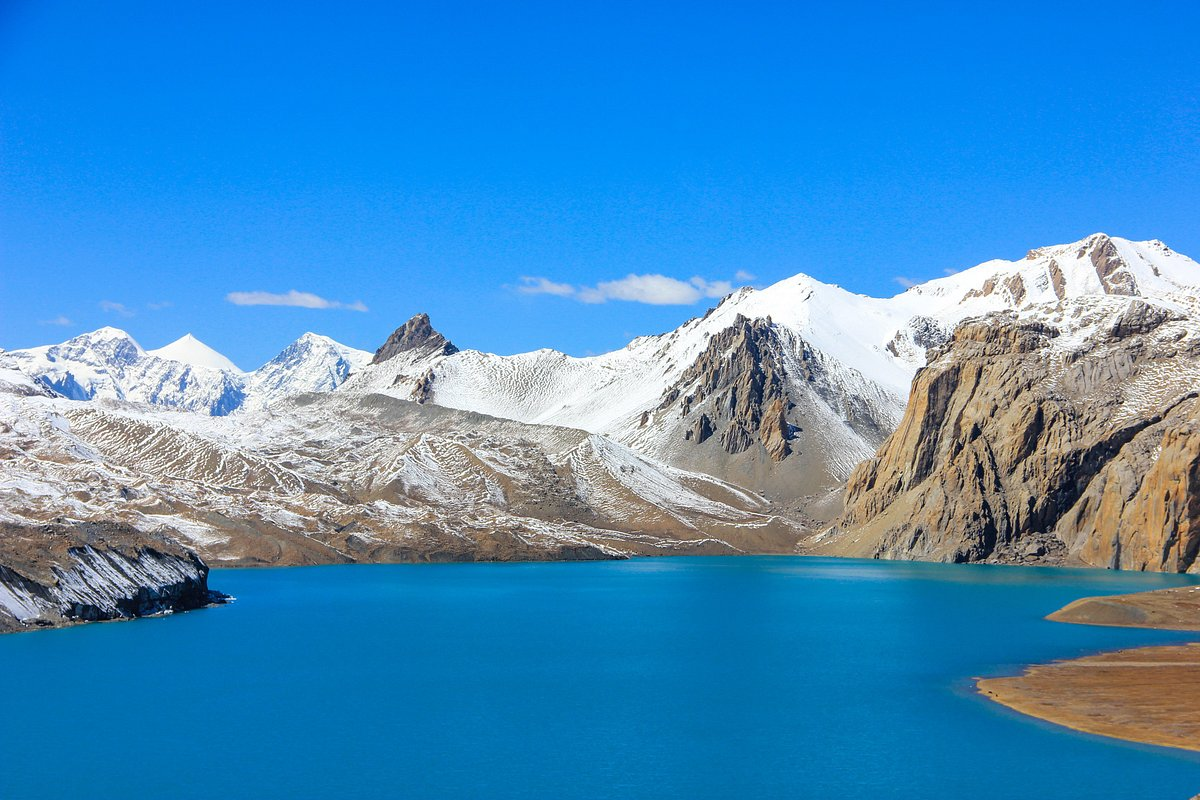Can you describe the colors and scenery in the image? The image presents a mesmerizing palette of colors. The lake's waters are a vivid, almost surreal shade of blue, contrasting sharply with the earthy tones of the mountains and the bright white of the snow-capped peaks. The clear sky is a deep, uninterrupted blue, enhancing the serene and untouched quality of the scene. The snow-covered mountains add a stark but beautiful contrast to the overall scenery, with their rugged, white peaks meeting the clear blue water and sky. 